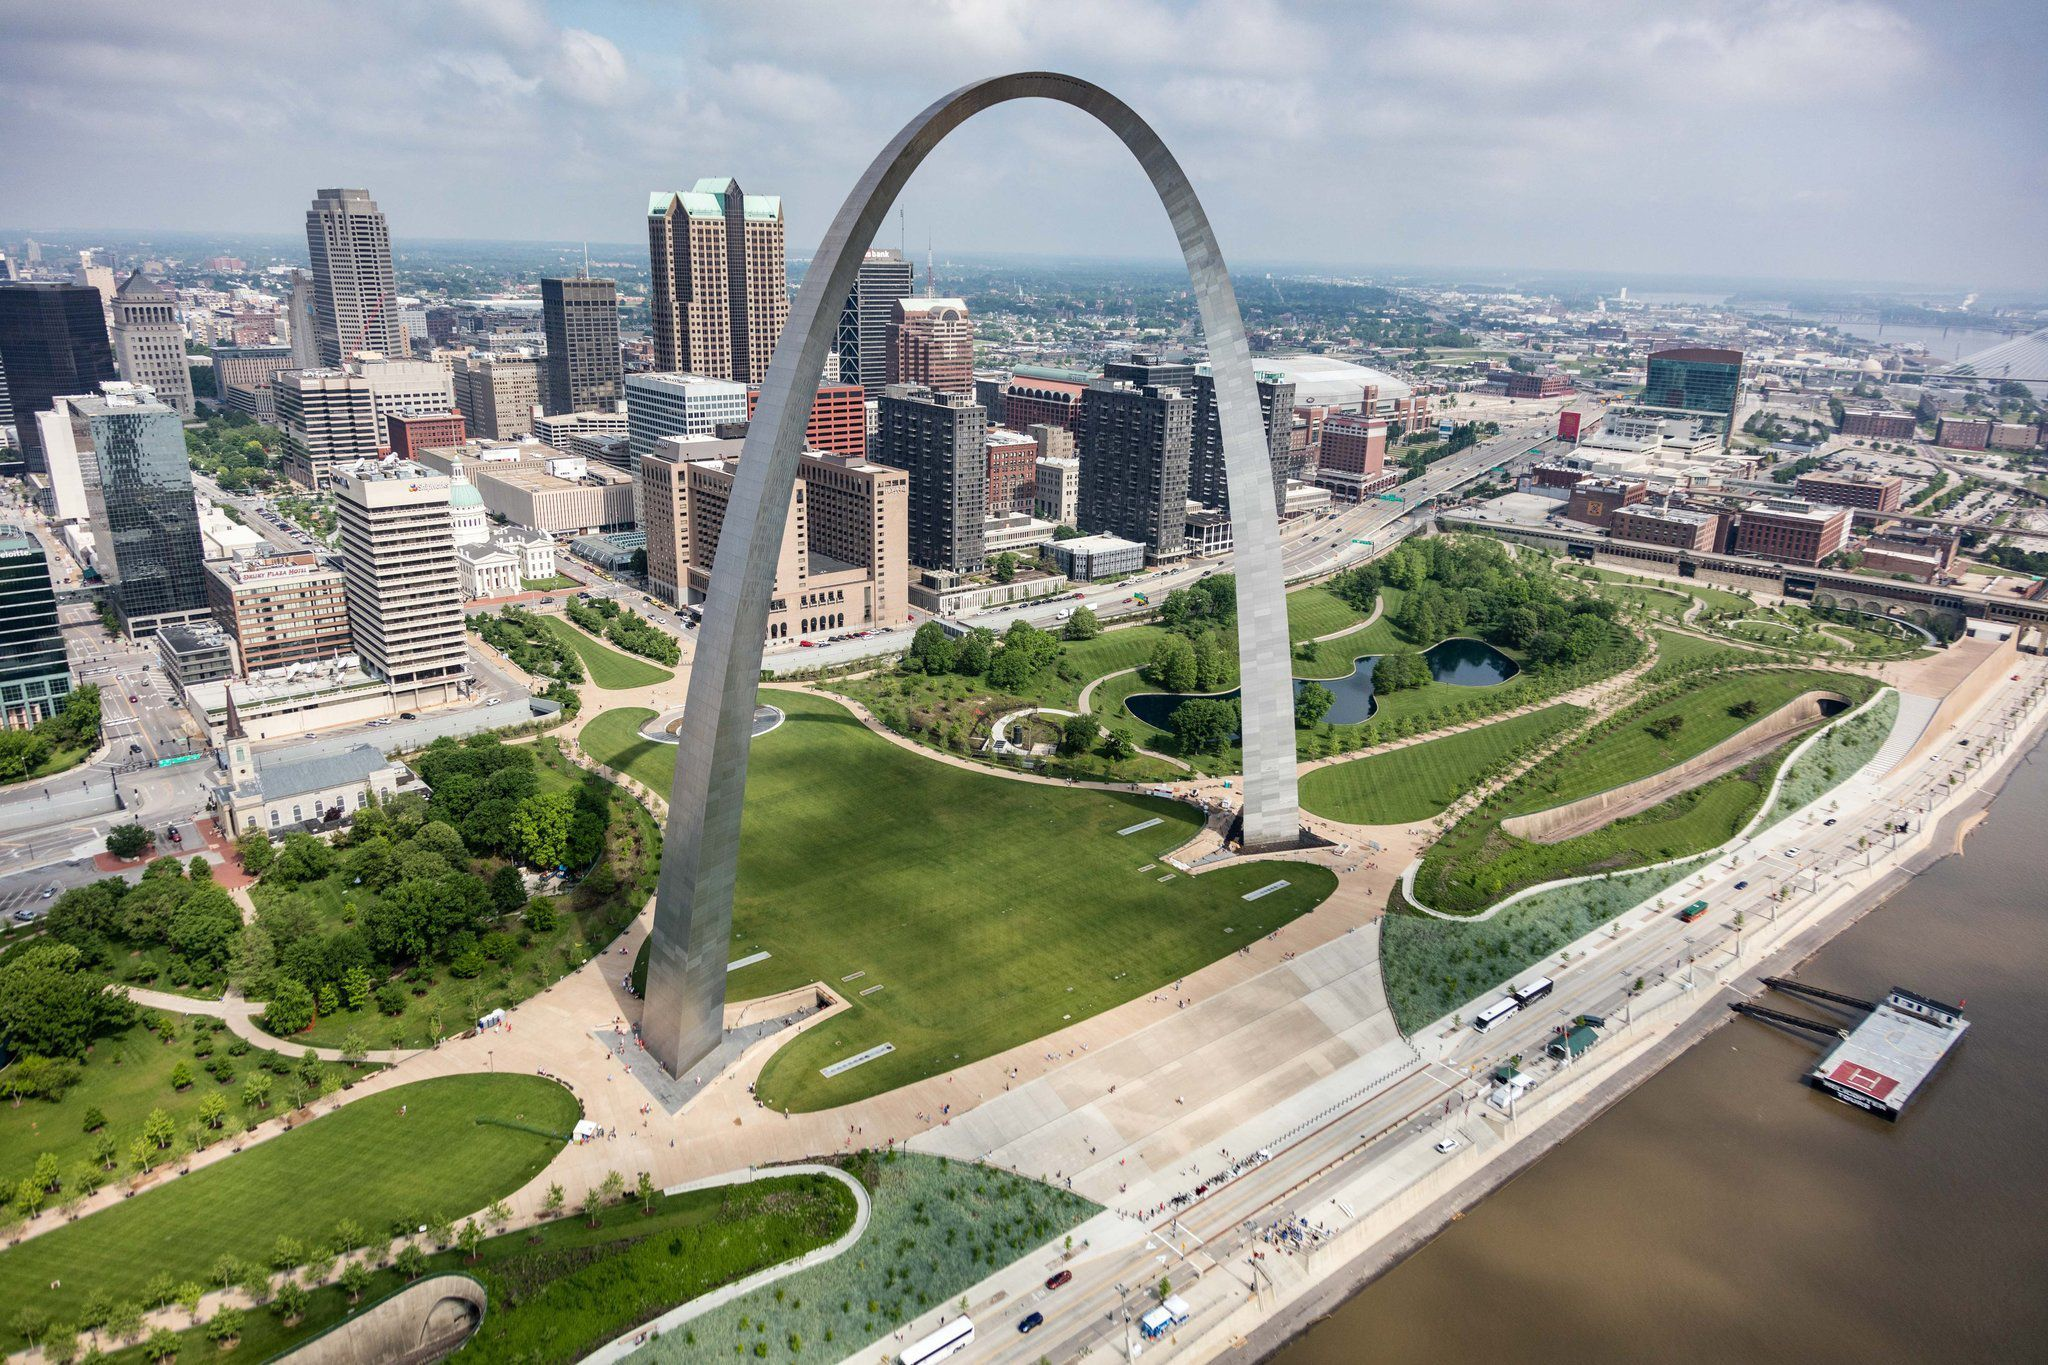Write a detailed description of the given image. The image captures a breathtaking aerial view of the Gateway Arch in St. Louis, Missouri. This iconic silver arch towers majestically over the city, standing as an emblem of innovation and progress. Nestled within an expanse of meticulously manicured greenery, the arch contrasts beautifully against the urban backdrop. The lush grass and trees below the arch provide a serene oasis amidst the hustle and bustle of city life. 

In the distance, St. Louis’s skyline is a tapestry of architectural styles, reflecting its rich history and dynamic growth. The Mississippi River flows to the right, a significant lifeline for the city, with a solitary boat gently navigating its waters, perhaps ferrying sightseers eager to explore the city’s charm. 

This high-angle shot comprehensively captures the grandeur of the arch and its surroundings. The perspective underscores the monument's awe-inspiring presence while simultaneously offering a glimpse into the vibrant life that flourishes in its shadow. This image eloquently weaves together elements of nature, architecture, and humanity, portraying St. Louis as a city that thrives at the intersection of history and modernity. 